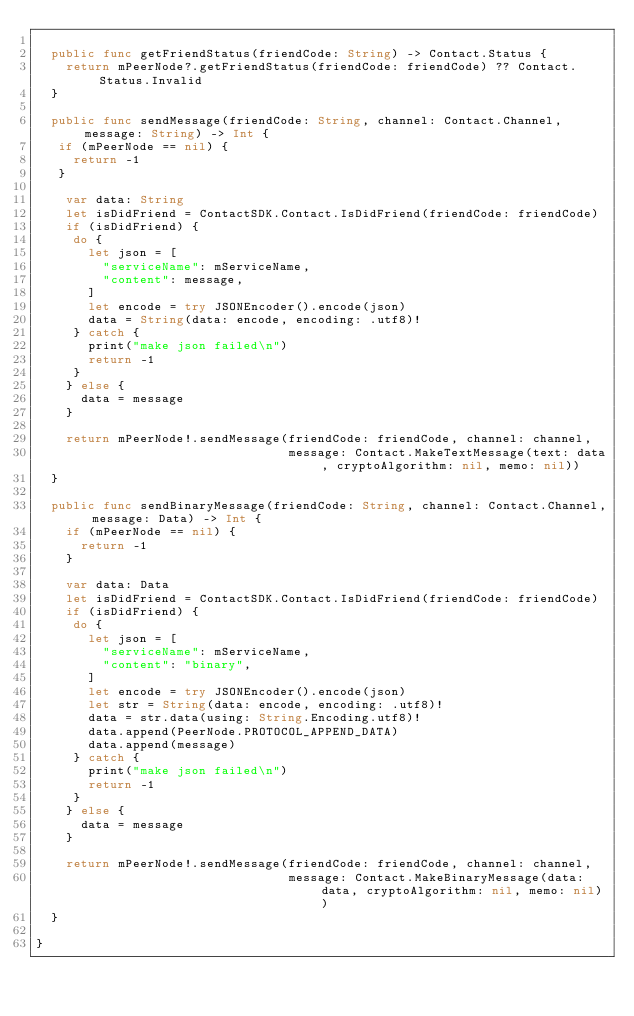<code> <loc_0><loc_0><loc_500><loc_500><_Swift_>  
  public func getFriendStatus(friendCode: String) -> Contact.Status {
    return mPeerNode?.getFriendStatus(friendCode: friendCode) ?? Contact.Status.Invalid
  }
  
  public func sendMessage(friendCode: String, channel: Contact.Channel, message: String) -> Int {
   if (mPeerNode == nil) {
     return -1
   }

    var data: String
    let isDidFriend = ContactSDK.Contact.IsDidFriend(friendCode: friendCode)
    if (isDidFriend) {
     do {
       let json = [
         "serviceName": mServiceName,
         "content": message,
       ]
       let encode = try JSONEncoder().encode(json)
       data = String(data: encode, encoding: .utf8)!
     } catch {
       print("make json failed\n")
       return -1
     }
    } else {
      data = message
    }
   
    return mPeerNode!.sendMessage(friendCode: friendCode, channel: channel,
                                  message: Contact.MakeTextMessage(text: data, cryptoAlgorithm: nil, memo: nil))
  }
  
  public func sendBinaryMessage(friendCode: String, channel: Contact.Channel, message: Data) -> Int {
    if (mPeerNode == nil) {
      return -1
    }

    var data: Data
    let isDidFriend = ContactSDK.Contact.IsDidFriend(friendCode: friendCode)
    if (isDidFriend) {
     do {
       let json = [
         "serviceName": mServiceName,
         "content": "binary",
       ]
       let encode = try JSONEncoder().encode(json)
       let str = String(data: encode, encoding: .utf8)!
       data = str.data(using: String.Encoding.utf8)!
       data.append(PeerNode.PROTOCOL_APPEND_DATA)
       data.append(message)
     } catch {
       print("make json failed\n")
       return -1
     }
    } else {
      data = message
    }

    return mPeerNode!.sendMessage(friendCode: friendCode, channel: channel,
                                  message: Contact.MakeBinaryMessage(data: data, cryptoAlgorithm: nil, memo: nil))
  }

}

</code> 